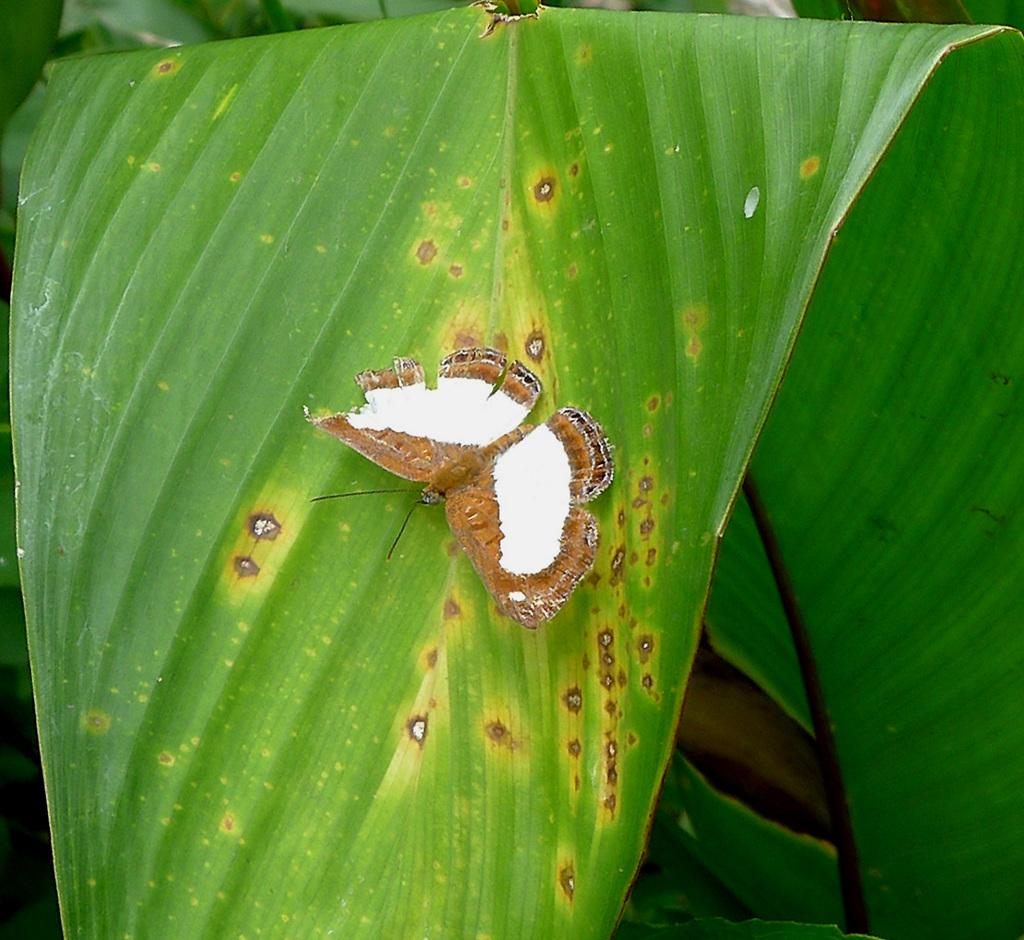What is the main subject of the image? There is a butterfly in the image. Where is the butterfly located? The butterfly is on a leaf. How many police officers are present in the image? There are no police officers present in the image; it features a butterfly on a leaf. What does the butterfly smell like in the image? The image does not provide information about the smell of the butterfly, as it is a visual representation. 